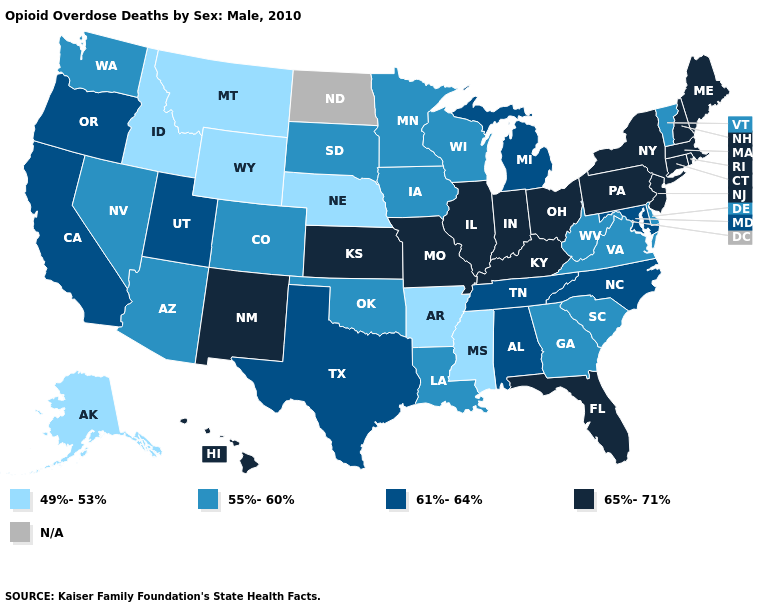Does Oklahoma have the lowest value in the South?
Give a very brief answer. No. What is the lowest value in the USA?
Give a very brief answer. 49%-53%. What is the lowest value in the USA?
Give a very brief answer. 49%-53%. What is the value of Alaska?
Answer briefly. 49%-53%. Does Rhode Island have the highest value in the Northeast?
Answer briefly. Yes. Which states have the lowest value in the USA?
Keep it brief. Alaska, Arkansas, Idaho, Mississippi, Montana, Nebraska, Wyoming. Name the states that have a value in the range 61%-64%?
Give a very brief answer. Alabama, California, Maryland, Michigan, North Carolina, Oregon, Tennessee, Texas, Utah. Which states have the lowest value in the USA?
Write a very short answer. Alaska, Arkansas, Idaho, Mississippi, Montana, Nebraska, Wyoming. Which states have the lowest value in the USA?
Write a very short answer. Alaska, Arkansas, Idaho, Mississippi, Montana, Nebraska, Wyoming. Which states hav the highest value in the Northeast?
Be succinct. Connecticut, Maine, Massachusetts, New Hampshire, New Jersey, New York, Pennsylvania, Rhode Island. Is the legend a continuous bar?
Answer briefly. No. Name the states that have a value in the range 55%-60%?
Quick response, please. Arizona, Colorado, Delaware, Georgia, Iowa, Louisiana, Minnesota, Nevada, Oklahoma, South Carolina, South Dakota, Vermont, Virginia, Washington, West Virginia, Wisconsin. Does Montana have the lowest value in the West?
Concise answer only. Yes. What is the value of Tennessee?
Concise answer only. 61%-64%. Name the states that have a value in the range 55%-60%?
Be succinct. Arizona, Colorado, Delaware, Georgia, Iowa, Louisiana, Minnesota, Nevada, Oklahoma, South Carolina, South Dakota, Vermont, Virginia, Washington, West Virginia, Wisconsin. 